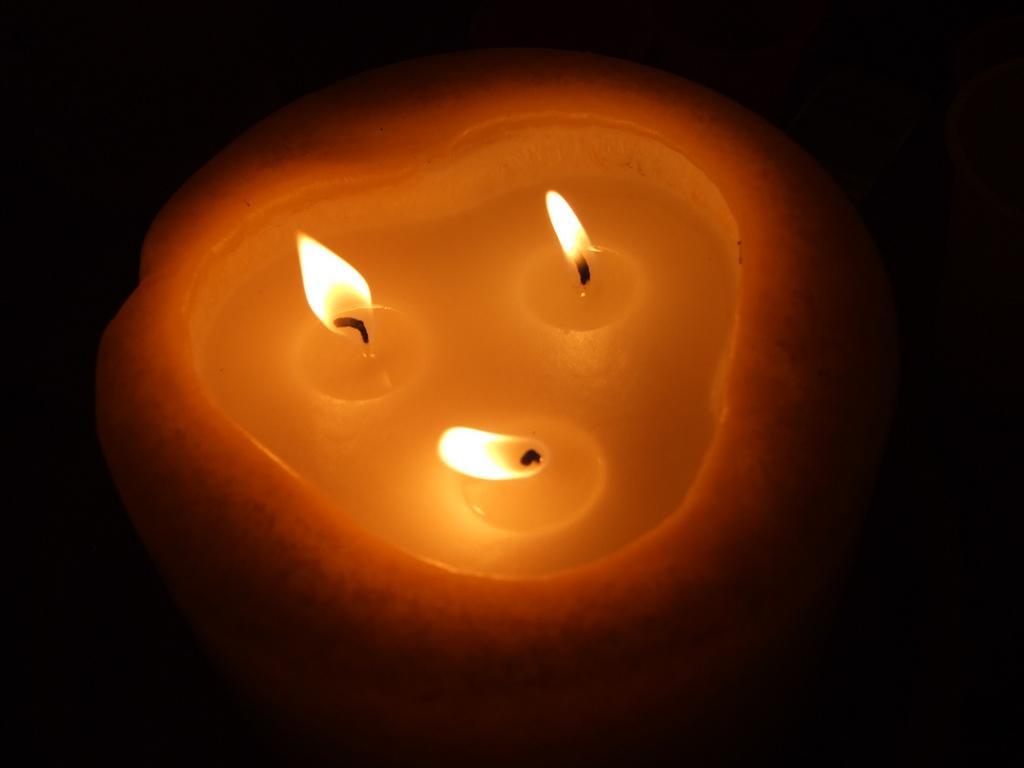Please provide a concise description of this image. In the image there is a illuminated candle and the background is black. 